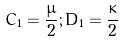Convert formula to latex. <formula><loc_0><loc_0><loc_500><loc_500>C _ { 1 } = \frac { \mu } { 2 } ; D _ { 1 } = \frac { \kappa } { 2 }</formula> 